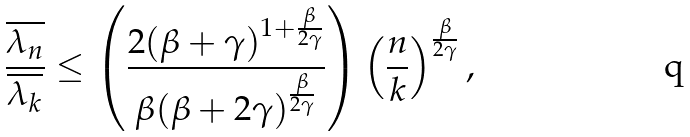<formula> <loc_0><loc_0><loc_500><loc_500>\frac { \overline { \lambda _ { n } } } { \overline { \lambda _ { k } } } \leq \left ( \frac { 2 ( \beta + \gamma ) ^ { 1 + \frac { \beta } { 2 \gamma } } } { \beta ( \beta + 2 \gamma ) ^ { \frac { \beta } { 2 \gamma } } } \right ) \left ( \frac { n } { k } \right ) ^ { \frac { \beta } { 2 \gamma } } ,</formula> 